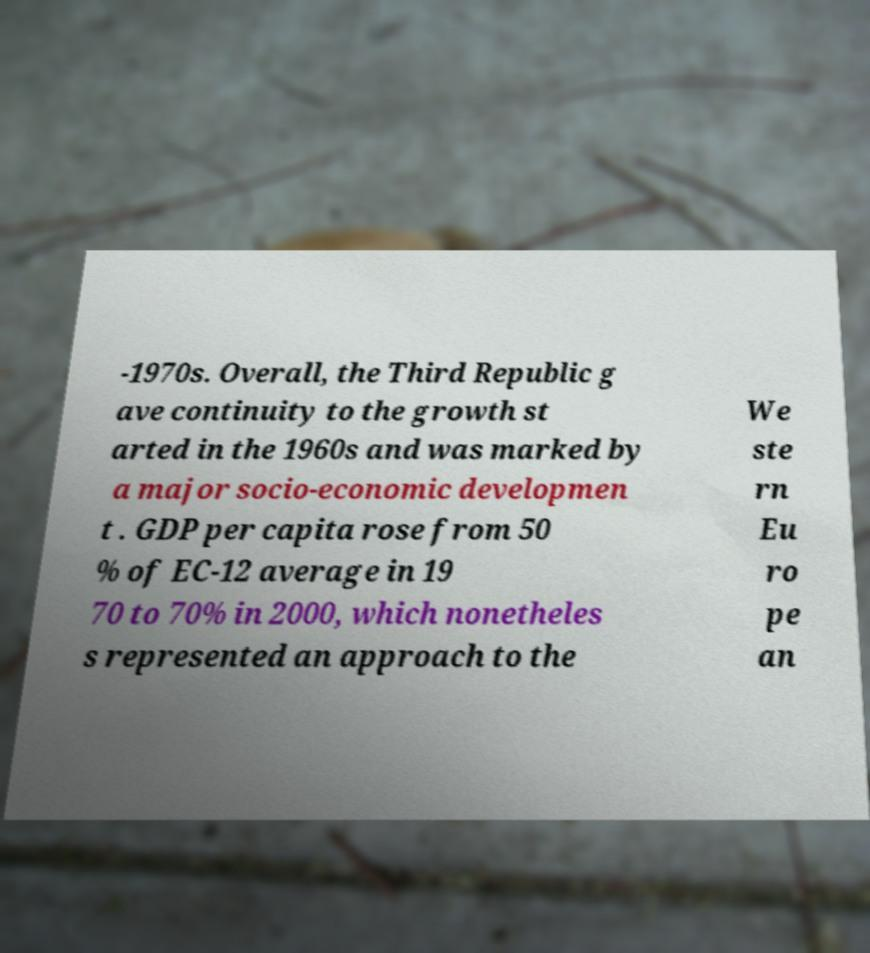What messages or text are displayed in this image? I need them in a readable, typed format. -1970s. Overall, the Third Republic g ave continuity to the growth st arted in the 1960s and was marked by a major socio-economic developmen t . GDP per capita rose from 50 % of EC-12 average in 19 70 to 70% in 2000, which nonetheles s represented an approach to the We ste rn Eu ro pe an 